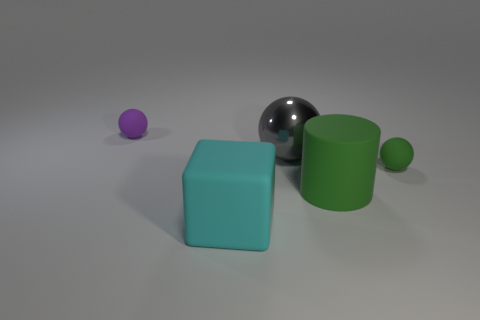Is the number of large cyan rubber things behind the green sphere greater than the number of gray spheres?
Give a very brief answer. No. The tiny object to the left of the big cube has what shape?
Make the answer very short. Sphere. What number of other things are the same shape as the gray shiny thing?
Your answer should be very brief. 2. Is the tiny object that is to the right of the gray sphere made of the same material as the large ball?
Your answer should be very brief. No. Are there the same number of tiny purple rubber spheres that are in front of the large cyan matte cube and green matte objects that are behind the matte cylinder?
Provide a short and direct response. No. There is a gray sphere right of the cyan object; how big is it?
Make the answer very short. Large. Are there any other cyan cubes that have the same material as the big cyan block?
Keep it short and to the point. No. Do the small matte object that is right of the big cube and the big rubber cylinder have the same color?
Your response must be concise. Yes. Is the number of big cubes that are behind the cube the same as the number of tiny brown rubber objects?
Ensure brevity in your answer.  Yes. Are there any other large balls that have the same color as the big metal ball?
Your response must be concise. No. 